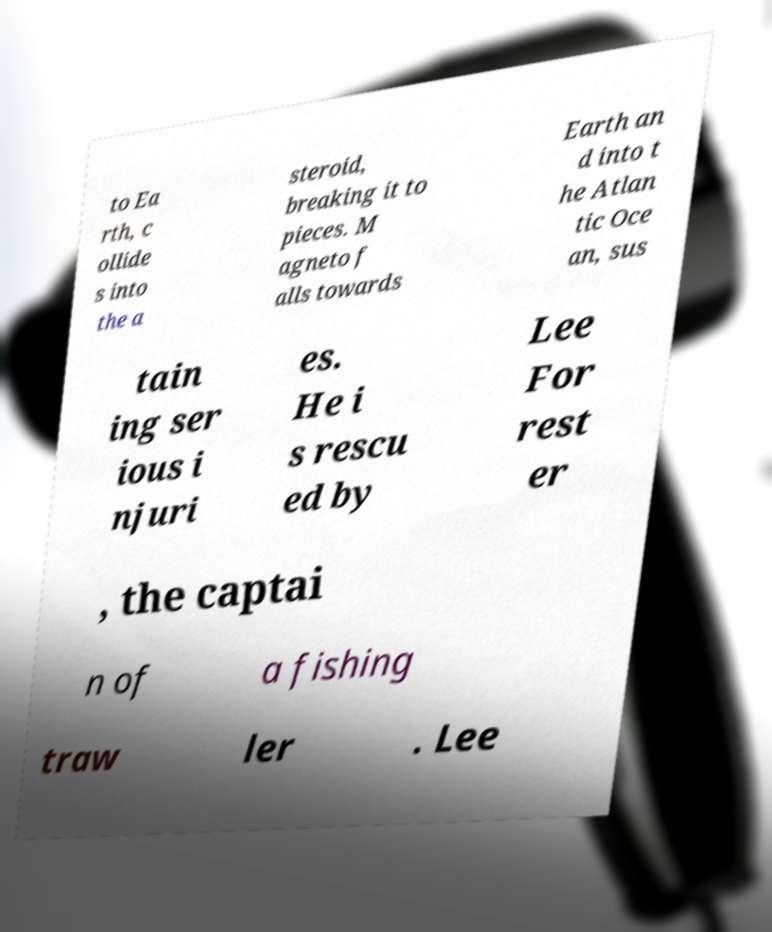Can you accurately transcribe the text from the provided image for me? to Ea rth, c ollide s into the a steroid, breaking it to pieces. M agneto f alls towards Earth an d into t he Atlan tic Oce an, sus tain ing ser ious i njuri es. He i s rescu ed by Lee For rest er , the captai n of a fishing traw ler . Lee 